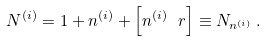Convert formula to latex. <formula><loc_0><loc_0><loc_500><loc_500>N ^ { ( i ) } = 1 + n ^ { ( i ) } + \left [ n ^ { ( i ) } \ r \right ] \equiv N _ { n ^ { ( i ) } } \, .</formula> 